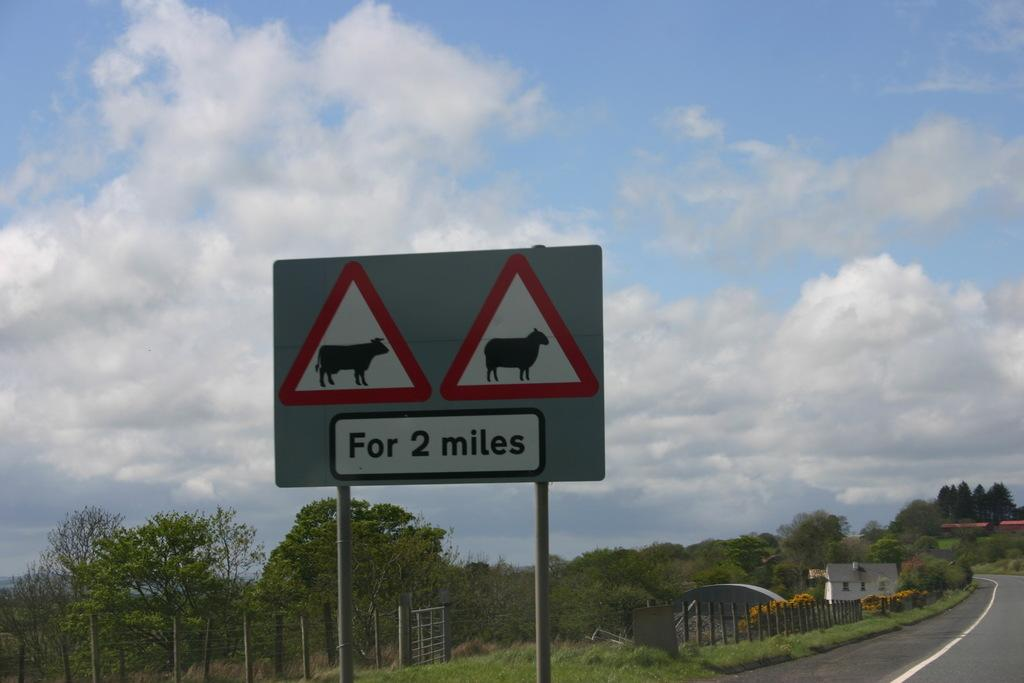Provide a one-sentence caption for the provided image. A sign warning drivers about farm animals for the next 2 miles is visible along a road. 